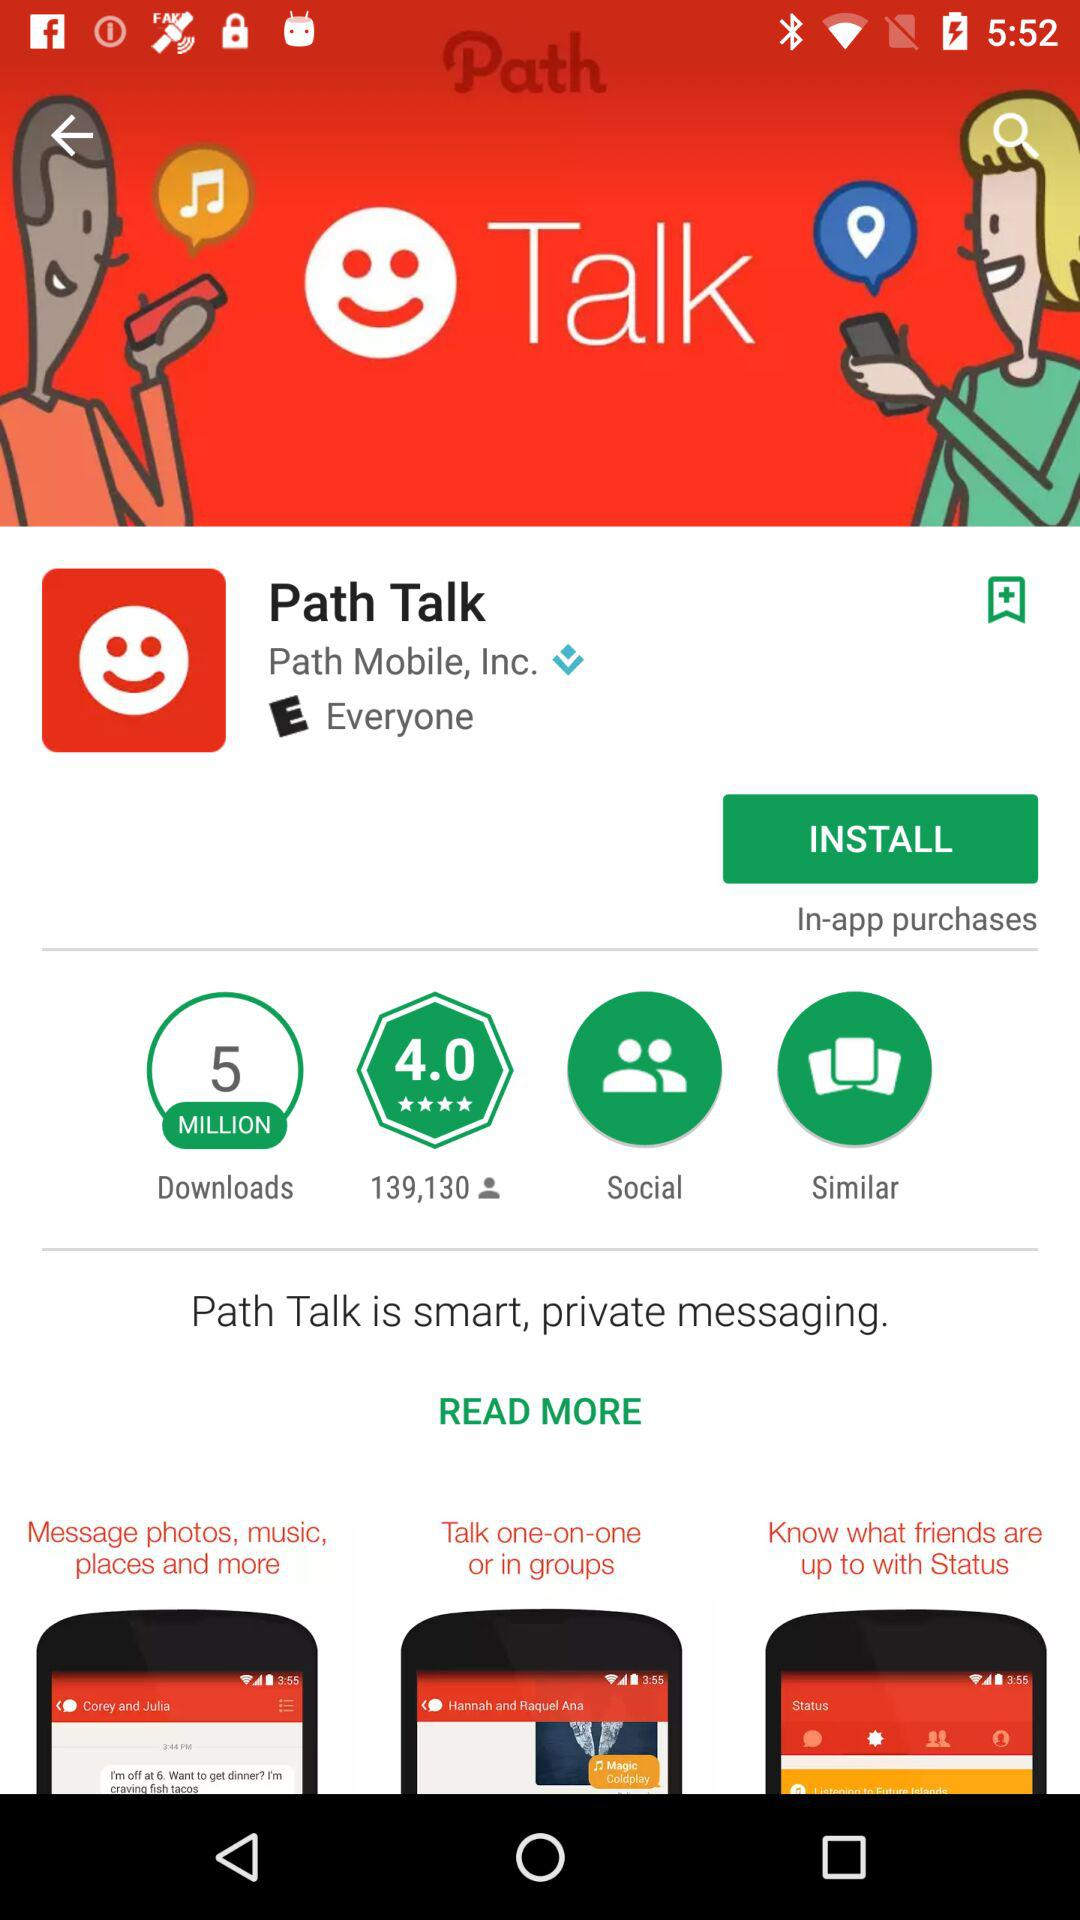What is the Application name? It is Path Talk. 